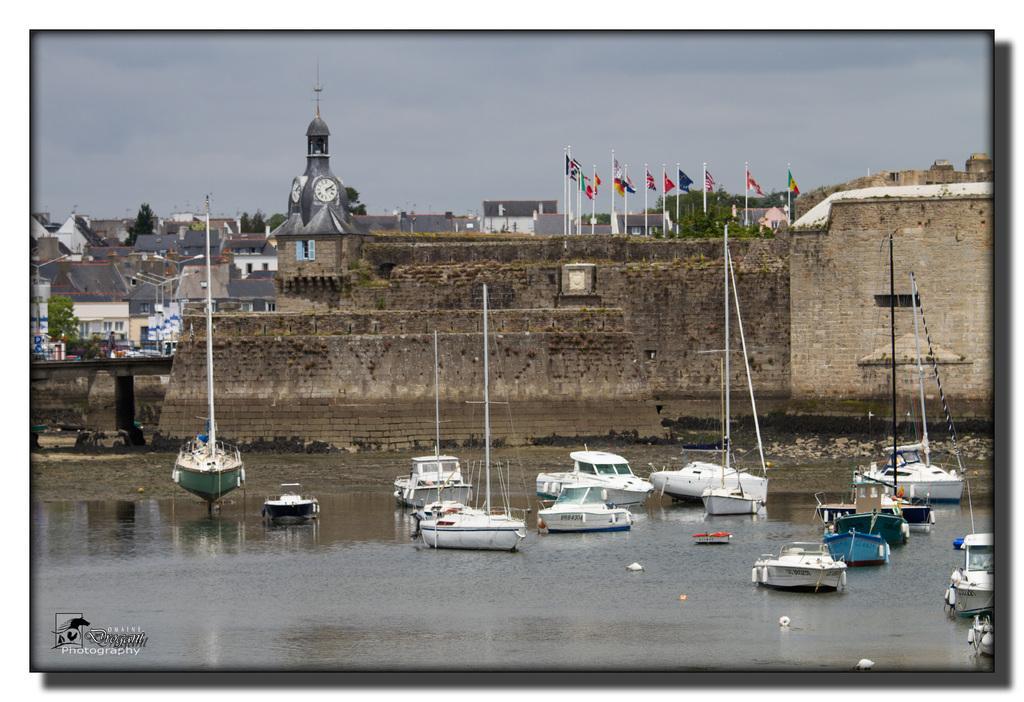Could you give a brief overview of what you see in this image? In this picture we can see boats on the water, walls, poles, flags, buildings, trees, some objects and in the background we can see the sky. 